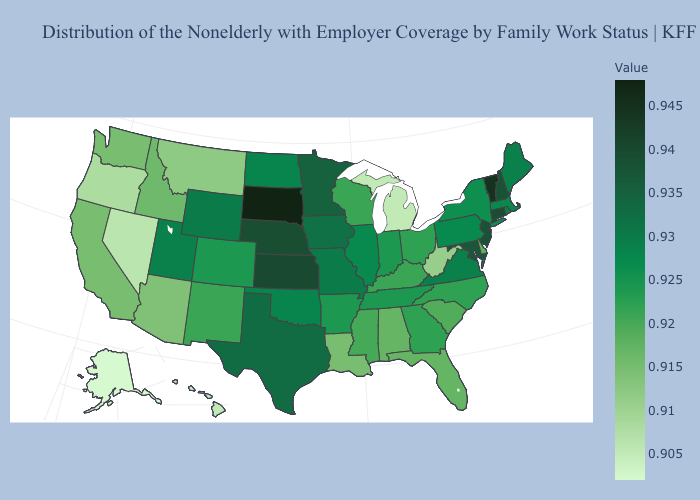Among the states that border Utah , which have the lowest value?
Answer briefly. Nevada. Does Maine have a higher value than Nevada?
Be succinct. Yes. Is the legend a continuous bar?
Be succinct. Yes. Does West Virginia have the highest value in the South?
Give a very brief answer. No. 